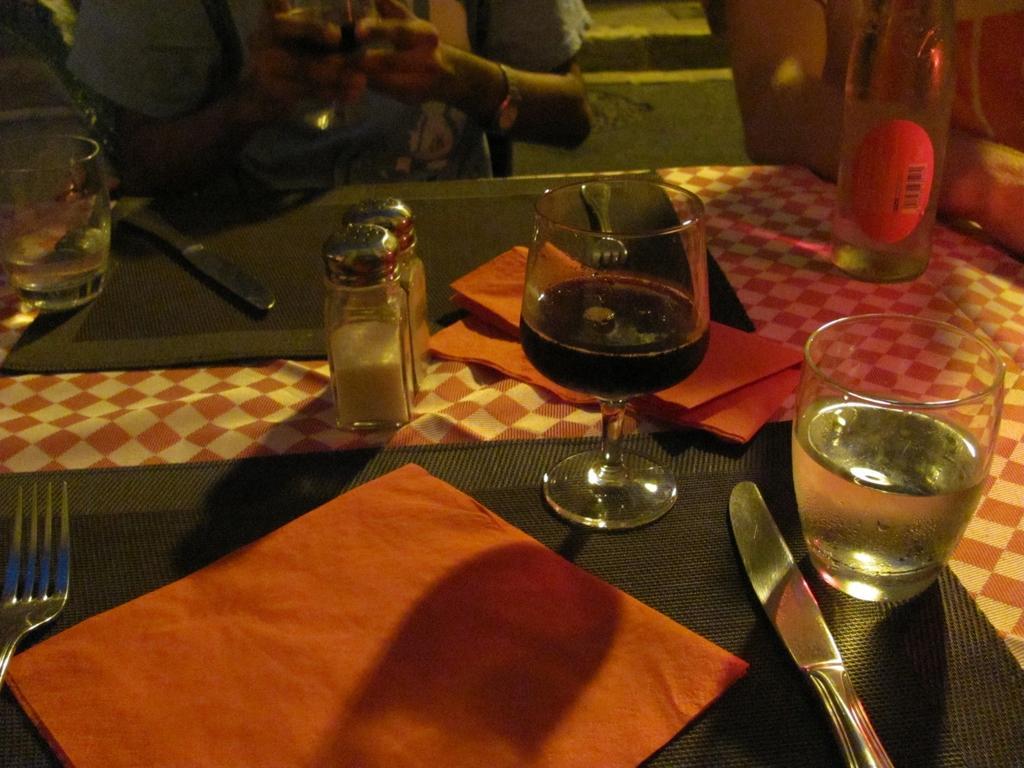Please provide a concise description of this image. In this picture there is a table in front of two people sitting, there is a knife, fork, napkin, water glass, a wine glass, sprinklers, there is also a water bottle kept on the table. 